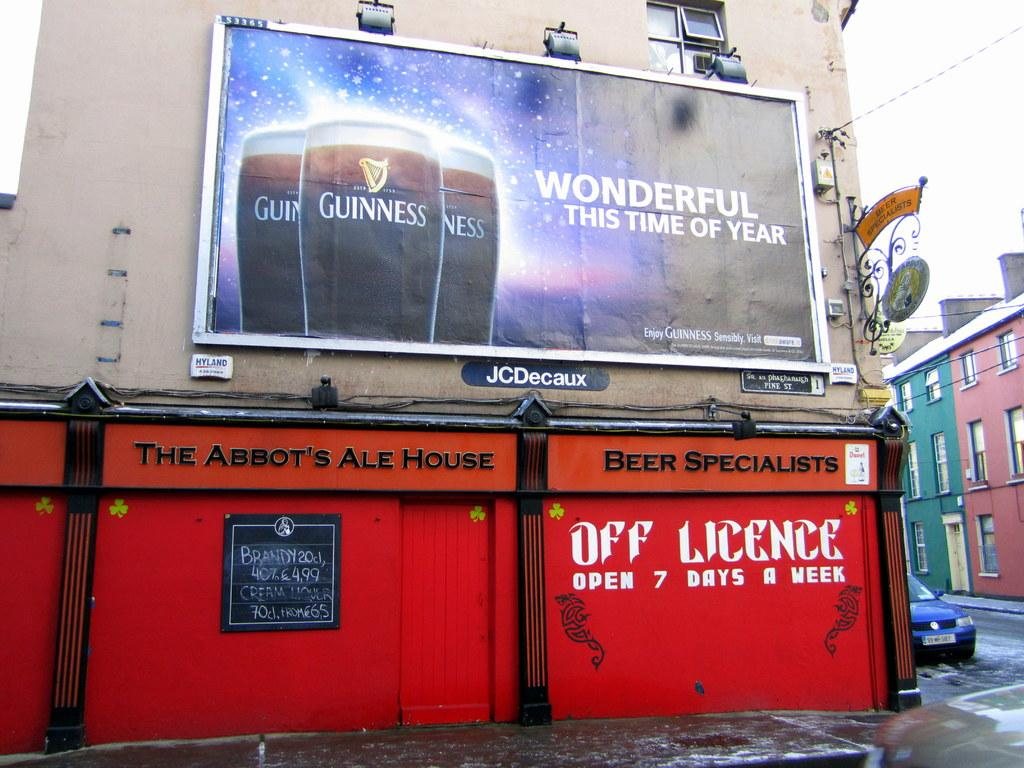Provide a one-sentence caption for the provided image. A Guiness billboard that says wonderful this time of year. 